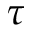<formula> <loc_0><loc_0><loc_500><loc_500>\tau</formula> 